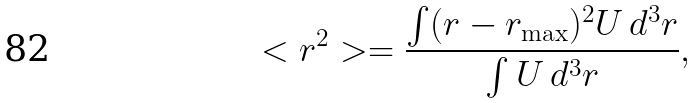Convert formula to latex. <formula><loc_0><loc_0><loc_500><loc_500>< r ^ { 2 } > = \frac { \int ( { r } - { r } _ { \max } ) ^ { 2 } U \, d ^ { 3 } r } { \int U \, d ^ { 3 } r } ,</formula> 